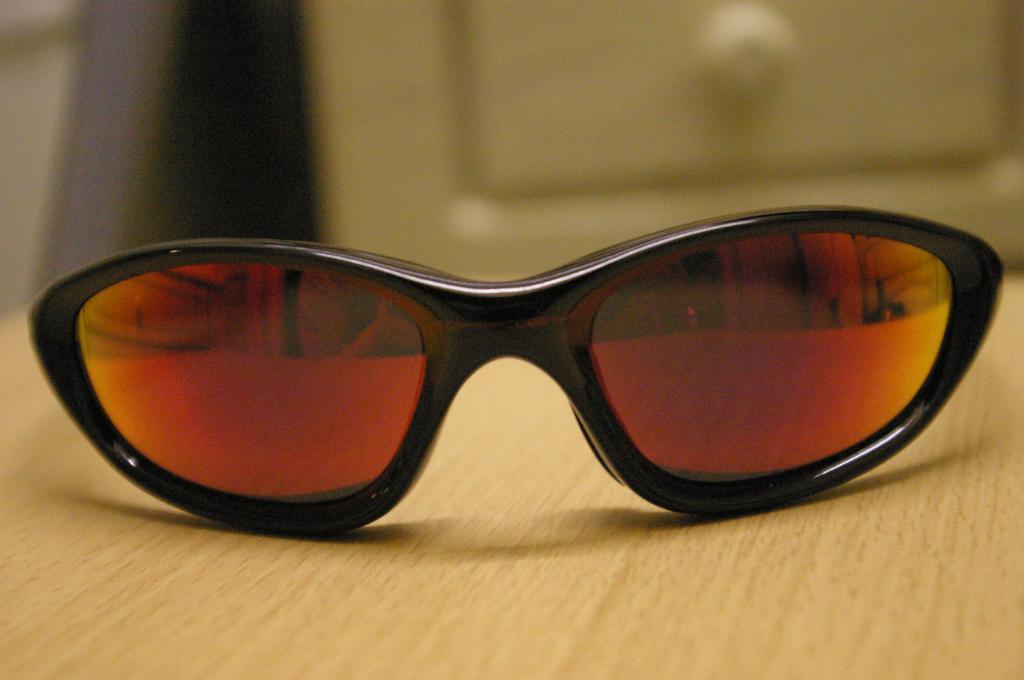Describe this image in one or two sentences. In this image we can see spectacles on the table with a blurry background. 